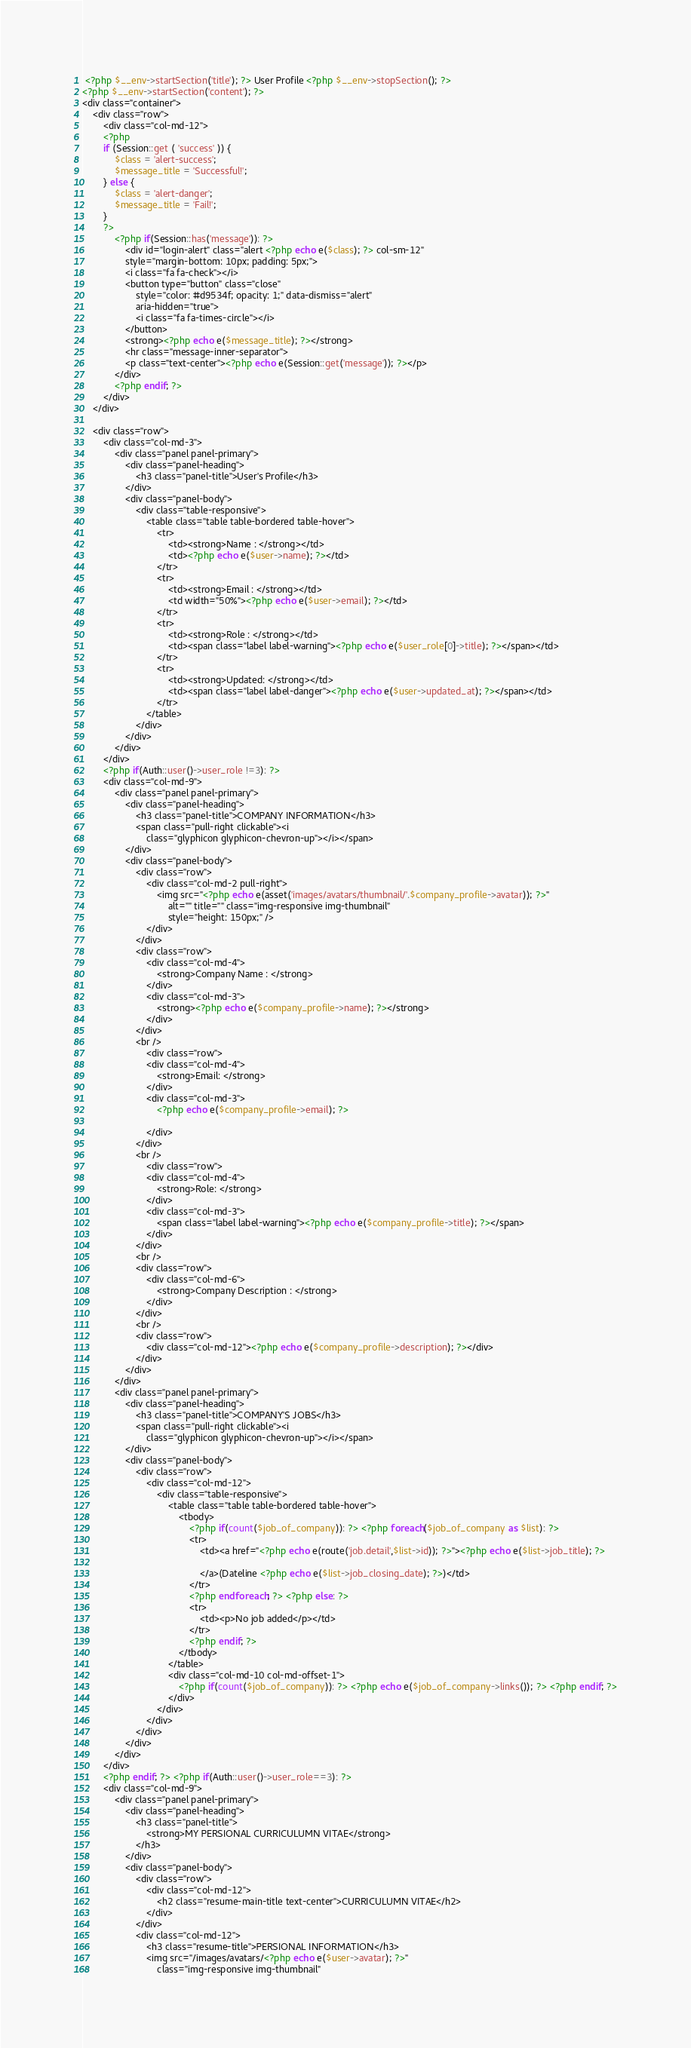<code> <loc_0><loc_0><loc_500><loc_500><_PHP_> <?php $__env->startSection('title'); ?> User Profile <?php $__env->stopSection(); ?>
<?php $__env->startSection('content'); ?>
<div class="container">
	<div class="row">
		<div class="col-md-12">
		<?php
		if (Session::get ( 'success' )) {
			$class = 'alert-success';
			$message_title = 'Successful!';
		} else {
			$class = 'alert-danger';
			$message_title = 'Fail!';
		}
		?>
			<?php if(Session::has('message')): ?>
	          	<div id="login-alert" class="alert <?php echo e($class); ?> col-sm-12"
				style="margin-bottom: 10px; padding: 5px;">
				<i class="fa fa-check"></i>
				<button type="button" class="close"
					style="color: #d9534f; opacity: 1;" data-dismiss="alert"
					aria-hidden="true">
					<i class="fa fa-times-circle"></i>
				</button>
				<strong><?php echo e($message_title); ?></strong>
				<hr class="message-inner-separator">
				<p class="text-center"><?php echo e(Session::get('message')); ?></p>
			</div>
			<?php endif; ?>
		</div>
	</div>

	<div class="row">
		<div class="col-md-3">
			<div class="panel panel-primary">
				<div class="panel-heading">
					<h3 class="panel-title">User's Profile</h3>
				</div>
				<div class="panel-body">
					<div class="table-responsive">
						<table class="table table-bordered table-hover">
							<tr>
								<td><strong>Name : </strong></td>
								<td><?php echo e($user->name); ?></td>
							</tr>
							<tr>
								<td><strong>Email : </strong></td>
								<td width="50%"><?php echo e($user->email); ?></td>
							</tr>
							<tr>
								<td><strong>Role : </strong></td>
								<td><span class="label label-warning"><?php echo e($user_role[0]->title); ?></span></td>
							</tr>
							<tr>
								<td><strong>Updated: </strong></td>
								<td><span class="label label-danger"><?php echo e($user->updated_at); ?></span></td>
							</tr>
						</table>
					</div>
				</div>
			</div>
		</div>
		<?php if(Auth::user()->user_role !=3): ?>
		<div class="col-md-9">
			<div class="panel panel-primary">
				<div class="panel-heading">
					<h3 class="panel-title">COMPANY INFORMATION</h3>
					<span class="pull-right clickable"><i
						class="glyphicon glyphicon-chevron-up"></i></span>
				</div>
				<div class="panel-body">
					<div class="row">
						<div class="col-md-2 pull-right">
							<img src="<?php echo e(asset('images/avatars/thumbnail/'.$company_profile->avatar)); ?>"
								alt="" title="" class="img-responsive img-thumbnail"
								style="height: 150px;" />
						</div>
					</div>
					<div class="row">
						<div class="col-md-4">
							<strong>Company Name : </strong>
						</div>
						<div class="col-md-3">
							<strong><?php echo e($company_profile->name); ?></strong>
						</div>
					</div>
					<br />
						<div class="row">
						<div class="col-md-4">
							<strong>Email: </strong>
						</div>
						<div class="col-md-3">
							<?php echo e($company_profile->email); ?>

						</div>
					</div>
					<br />
						<div class="row">
						<div class="col-md-4">
							<strong>Role: </strong>
						</div>
						<div class="col-md-3">
							<span class="label label-warning"><?php echo e($company_profile->title); ?></span>
						</div>
					</div>
					<br />
					<div class="row">
						<div class="col-md-6">
							<strong>Company Description : </strong>
						</div>
					</div>
					<br />
					<div class="row">
						<div class="col-md-12"><?php echo e($company_profile->description); ?></div>
					</div>
				</div>
			</div>
			<div class="panel panel-primary">
				<div class="panel-heading">
					<h3 class="panel-title">COMPANY'S JOBS</h3>
					<span class="pull-right clickable"><i
						class="glyphicon glyphicon-chevron-up"></i></span>
				</div>
				<div class="panel-body">
					<div class="row">
						<div class="col-md-12">
							<div class="table-responsive">
								<table class="table table-bordered table-hover">
									<tbody>
										<?php if(count($job_of_company)): ?> <?php foreach($job_of_company as $list): ?>
										<tr>
											<td><a href="<?php echo e(route('job.detail',$list->id)); ?>"><?php echo e($list->job_title); ?>

											</a>(Dateline <?php echo e($list->job_closing_date); ?>)</td>
										</tr>
										<?php endforeach; ?> <?php else: ?>
										<tr>
											<td><p>No job added</p></td>
										</tr>
										<?php endif; ?>
									</tbody>
								</table>
								<div class="col-md-10 col-md-offset-1">
									<?php if(count($job_of_company)): ?> <?php echo e($job_of_company->links()); ?> <?php endif; ?>
								</div>
							</div>
						</div>
					</div>
				</div>
			</div>
		</div>
		<?php endif; ?> <?php if(Auth::user()->user_role==3): ?>
		<div class="col-md-9">
			<div class="panel panel-primary">
				<div class="panel-heading">
					<h3 class="panel-title">
						<strong>MY PERSIONAL CURRICULUMN VITAE</strong>
					</h3>
				</div>
				<div class="panel-body">
					<div class="row">
						<div class="col-md-12">
							<h2 class="resume-main-title text-center">CURRICULUMN VITAE</h2>
						</div>
					</div>
					<div class="col-md-12">
						<h3 class="resume-title">PERSIONAL INFORMATION</h3>
						<img src="/images/avatars/<?php echo e($user->avatar); ?>"
							class="img-responsive img-thumbnail"</code> 